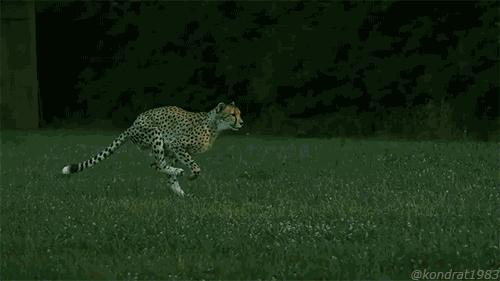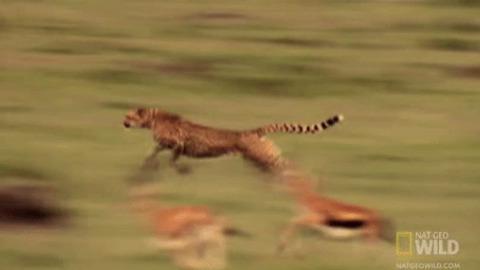The first image is the image on the left, the second image is the image on the right. Considering the images on both sides, is "In at least one image there is a single cheete with it's paw touch the elk it is chasing down." valid? Answer yes or no. No. The first image is the image on the left, the second image is the image on the right. Examine the images to the left and right. Is the description "In one image, a cheetah is about to capture a hooved animal as the cat strikes from behind the leftward-moving prey." accurate? Answer yes or no. No. 